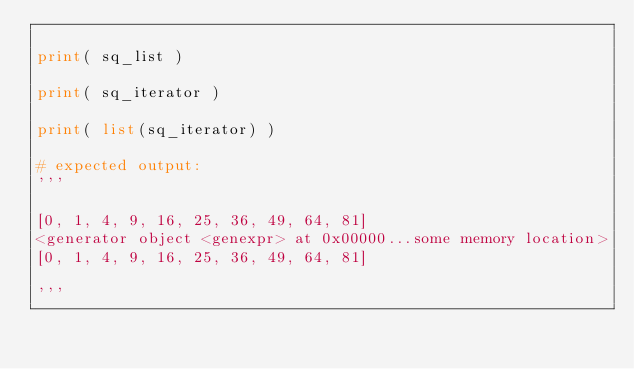<code> <loc_0><loc_0><loc_500><loc_500><_Python_>
print( sq_list )

print( sq_iterator )

print( list(sq_iterator) )

# expected output:
'''

[0, 1, 4, 9, 16, 25, 36, 49, 64, 81]
<generator object <genexpr> at 0x00000...some memory location>
[0, 1, 4, 9, 16, 25, 36, 49, 64, 81]

'''</code> 